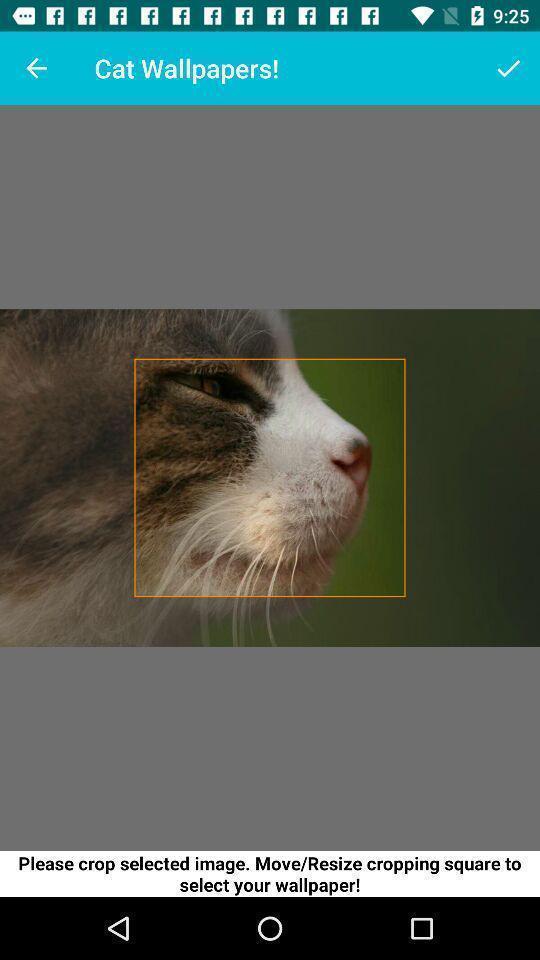Provide a detailed account of this screenshot. Page shows an image in the wallpaper app. 